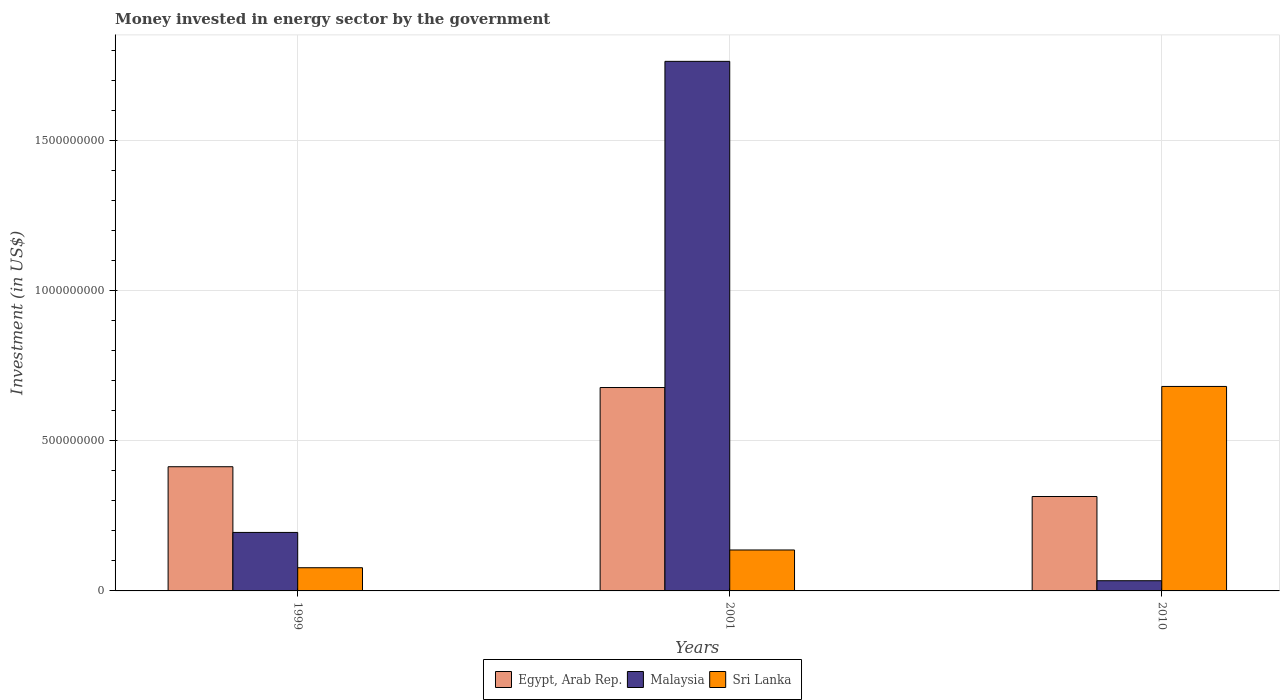How many different coloured bars are there?
Provide a succinct answer. 3. How many groups of bars are there?
Give a very brief answer. 3. Are the number of bars on each tick of the X-axis equal?
Keep it short and to the point. Yes. How many bars are there on the 3rd tick from the left?
Offer a terse response. 3. What is the label of the 2nd group of bars from the left?
Ensure brevity in your answer.  2001. In how many cases, is the number of bars for a given year not equal to the number of legend labels?
Make the answer very short. 0. What is the money spent in energy sector in Sri Lanka in 2010?
Offer a very short reply. 6.82e+08. Across all years, what is the maximum money spent in energy sector in Egypt, Arab Rep.?
Make the answer very short. 6.78e+08. Across all years, what is the minimum money spent in energy sector in Egypt, Arab Rep.?
Your answer should be very brief. 3.15e+08. In which year was the money spent in energy sector in Sri Lanka minimum?
Keep it short and to the point. 1999. What is the total money spent in energy sector in Sri Lanka in the graph?
Offer a very short reply. 8.95e+08. What is the difference between the money spent in energy sector in Sri Lanka in 1999 and that in 2001?
Give a very brief answer. -5.92e+07. What is the difference between the money spent in energy sector in Egypt, Arab Rep. in 2010 and the money spent in energy sector in Sri Lanka in 2001?
Your answer should be very brief. 1.78e+08. What is the average money spent in energy sector in Sri Lanka per year?
Make the answer very short. 2.98e+08. In the year 2010, what is the difference between the money spent in energy sector in Sri Lanka and money spent in energy sector in Malaysia?
Make the answer very short. 6.48e+08. In how many years, is the money spent in energy sector in Malaysia greater than 400000000 US$?
Offer a terse response. 1. What is the ratio of the money spent in energy sector in Egypt, Arab Rep. in 2001 to that in 2010?
Make the answer very short. 2.15. What is the difference between the highest and the second highest money spent in energy sector in Malaysia?
Keep it short and to the point. 1.57e+09. What is the difference between the highest and the lowest money spent in energy sector in Malaysia?
Provide a short and direct response. 1.73e+09. In how many years, is the money spent in energy sector in Sri Lanka greater than the average money spent in energy sector in Sri Lanka taken over all years?
Provide a succinct answer. 1. Is the sum of the money spent in energy sector in Malaysia in 2001 and 2010 greater than the maximum money spent in energy sector in Egypt, Arab Rep. across all years?
Your response must be concise. Yes. What does the 1st bar from the left in 1999 represents?
Keep it short and to the point. Egypt, Arab Rep. What does the 2nd bar from the right in 2010 represents?
Give a very brief answer. Malaysia. Is it the case that in every year, the sum of the money spent in energy sector in Sri Lanka and money spent in energy sector in Malaysia is greater than the money spent in energy sector in Egypt, Arab Rep.?
Provide a succinct answer. No. Are all the bars in the graph horizontal?
Provide a succinct answer. No. Does the graph contain any zero values?
Your answer should be very brief. No. Does the graph contain grids?
Provide a short and direct response. Yes. Where does the legend appear in the graph?
Your answer should be very brief. Bottom center. What is the title of the graph?
Give a very brief answer. Money invested in energy sector by the government. What is the label or title of the X-axis?
Your response must be concise. Years. What is the label or title of the Y-axis?
Give a very brief answer. Investment (in US$). What is the Investment (in US$) of Egypt, Arab Rep. in 1999?
Provide a short and direct response. 4.14e+08. What is the Investment (in US$) in Malaysia in 1999?
Offer a very short reply. 1.95e+08. What is the Investment (in US$) in Sri Lanka in 1999?
Provide a succinct answer. 7.73e+07. What is the Investment (in US$) in Egypt, Arab Rep. in 2001?
Provide a succinct answer. 6.78e+08. What is the Investment (in US$) of Malaysia in 2001?
Provide a short and direct response. 1.77e+09. What is the Investment (in US$) in Sri Lanka in 2001?
Provide a succinct answer. 1.36e+08. What is the Investment (in US$) in Egypt, Arab Rep. in 2010?
Keep it short and to the point. 3.15e+08. What is the Investment (in US$) of Malaysia in 2010?
Give a very brief answer. 3.40e+07. What is the Investment (in US$) of Sri Lanka in 2010?
Make the answer very short. 6.82e+08. Across all years, what is the maximum Investment (in US$) in Egypt, Arab Rep.?
Make the answer very short. 6.78e+08. Across all years, what is the maximum Investment (in US$) of Malaysia?
Give a very brief answer. 1.77e+09. Across all years, what is the maximum Investment (in US$) in Sri Lanka?
Your response must be concise. 6.82e+08. Across all years, what is the minimum Investment (in US$) of Egypt, Arab Rep.?
Give a very brief answer. 3.15e+08. Across all years, what is the minimum Investment (in US$) in Malaysia?
Your answer should be very brief. 3.40e+07. Across all years, what is the minimum Investment (in US$) in Sri Lanka?
Give a very brief answer. 7.73e+07. What is the total Investment (in US$) of Egypt, Arab Rep. in the graph?
Make the answer very short. 1.41e+09. What is the total Investment (in US$) of Malaysia in the graph?
Provide a short and direct response. 1.99e+09. What is the total Investment (in US$) in Sri Lanka in the graph?
Your answer should be very brief. 8.95e+08. What is the difference between the Investment (in US$) of Egypt, Arab Rep. in 1999 and that in 2001?
Your response must be concise. -2.64e+08. What is the difference between the Investment (in US$) in Malaysia in 1999 and that in 2001?
Your answer should be compact. -1.57e+09. What is the difference between the Investment (in US$) in Sri Lanka in 1999 and that in 2001?
Make the answer very short. -5.92e+07. What is the difference between the Investment (in US$) of Egypt, Arab Rep. in 1999 and that in 2010?
Make the answer very short. 9.93e+07. What is the difference between the Investment (in US$) in Malaysia in 1999 and that in 2010?
Your response must be concise. 1.61e+08. What is the difference between the Investment (in US$) in Sri Lanka in 1999 and that in 2010?
Keep it short and to the point. -6.04e+08. What is the difference between the Investment (in US$) in Egypt, Arab Rep. in 2001 and that in 2010?
Your response must be concise. 3.63e+08. What is the difference between the Investment (in US$) of Malaysia in 2001 and that in 2010?
Offer a very short reply. 1.73e+09. What is the difference between the Investment (in US$) in Sri Lanka in 2001 and that in 2010?
Your response must be concise. -5.45e+08. What is the difference between the Investment (in US$) of Egypt, Arab Rep. in 1999 and the Investment (in US$) of Malaysia in 2001?
Offer a terse response. -1.35e+09. What is the difference between the Investment (in US$) in Egypt, Arab Rep. in 1999 and the Investment (in US$) in Sri Lanka in 2001?
Ensure brevity in your answer.  2.78e+08. What is the difference between the Investment (in US$) of Malaysia in 1999 and the Investment (in US$) of Sri Lanka in 2001?
Give a very brief answer. 5.85e+07. What is the difference between the Investment (in US$) in Egypt, Arab Rep. in 1999 and the Investment (in US$) in Malaysia in 2010?
Keep it short and to the point. 3.80e+08. What is the difference between the Investment (in US$) of Egypt, Arab Rep. in 1999 and the Investment (in US$) of Sri Lanka in 2010?
Your answer should be very brief. -2.68e+08. What is the difference between the Investment (in US$) in Malaysia in 1999 and the Investment (in US$) in Sri Lanka in 2010?
Your answer should be very brief. -4.87e+08. What is the difference between the Investment (in US$) of Egypt, Arab Rep. in 2001 and the Investment (in US$) of Malaysia in 2010?
Make the answer very short. 6.44e+08. What is the difference between the Investment (in US$) in Egypt, Arab Rep. in 2001 and the Investment (in US$) in Sri Lanka in 2010?
Your answer should be compact. -3.60e+06. What is the difference between the Investment (in US$) of Malaysia in 2001 and the Investment (in US$) of Sri Lanka in 2010?
Your answer should be very brief. 1.08e+09. What is the average Investment (in US$) of Egypt, Arab Rep. per year?
Provide a succinct answer. 4.69e+08. What is the average Investment (in US$) in Malaysia per year?
Make the answer very short. 6.65e+08. What is the average Investment (in US$) in Sri Lanka per year?
Make the answer very short. 2.98e+08. In the year 1999, what is the difference between the Investment (in US$) of Egypt, Arab Rep. and Investment (in US$) of Malaysia?
Offer a very short reply. 2.19e+08. In the year 1999, what is the difference between the Investment (in US$) of Egypt, Arab Rep. and Investment (in US$) of Sri Lanka?
Ensure brevity in your answer.  3.37e+08. In the year 1999, what is the difference between the Investment (in US$) in Malaysia and Investment (in US$) in Sri Lanka?
Provide a succinct answer. 1.18e+08. In the year 2001, what is the difference between the Investment (in US$) of Egypt, Arab Rep. and Investment (in US$) of Malaysia?
Your answer should be very brief. -1.09e+09. In the year 2001, what is the difference between the Investment (in US$) of Egypt, Arab Rep. and Investment (in US$) of Sri Lanka?
Offer a terse response. 5.42e+08. In the year 2001, what is the difference between the Investment (in US$) of Malaysia and Investment (in US$) of Sri Lanka?
Provide a succinct answer. 1.63e+09. In the year 2010, what is the difference between the Investment (in US$) in Egypt, Arab Rep. and Investment (in US$) in Malaysia?
Keep it short and to the point. 2.81e+08. In the year 2010, what is the difference between the Investment (in US$) in Egypt, Arab Rep. and Investment (in US$) in Sri Lanka?
Your answer should be compact. -3.67e+08. In the year 2010, what is the difference between the Investment (in US$) in Malaysia and Investment (in US$) in Sri Lanka?
Ensure brevity in your answer.  -6.48e+08. What is the ratio of the Investment (in US$) in Egypt, Arab Rep. in 1999 to that in 2001?
Give a very brief answer. 0.61. What is the ratio of the Investment (in US$) of Malaysia in 1999 to that in 2001?
Give a very brief answer. 0.11. What is the ratio of the Investment (in US$) in Sri Lanka in 1999 to that in 2001?
Provide a succinct answer. 0.57. What is the ratio of the Investment (in US$) in Egypt, Arab Rep. in 1999 to that in 2010?
Your answer should be compact. 1.32. What is the ratio of the Investment (in US$) in Malaysia in 1999 to that in 2010?
Provide a succinct answer. 5.74. What is the ratio of the Investment (in US$) of Sri Lanka in 1999 to that in 2010?
Ensure brevity in your answer.  0.11. What is the ratio of the Investment (in US$) of Egypt, Arab Rep. in 2001 to that in 2010?
Your answer should be very brief. 2.15. What is the ratio of the Investment (in US$) of Malaysia in 2001 to that in 2010?
Your answer should be very brief. 51.92. What is the ratio of the Investment (in US$) of Sri Lanka in 2001 to that in 2010?
Offer a very short reply. 0.2. What is the difference between the highest and the second highest Investment (in US$) of Egypt, Arab Rep.?
Ensure brevity in your answer.  2.64e+08. What is the difference between the highest and the second highest Investment (in US$) in Malaysia?
Give a very brief answer. 1.57e+09. What is the difference between the highest and the second highest Investment (in US$) in Sri Lanka?
Your answer should be compact. 5.45e+08. What is the difference between the highest and the lowest Investment (in US$) in Egypt, Arab Rep.?
Keep it short and to the point. 3.63e+08. What is the difference between the highest and the lowest Investment (in US$) of Malaysia?
Make the answer very short. 1.73e+09. What is the difference between the highest and the lowest Investment (in US$) in Sri Lanka?
Ensure brevity in your answer.  6.04e+08. 